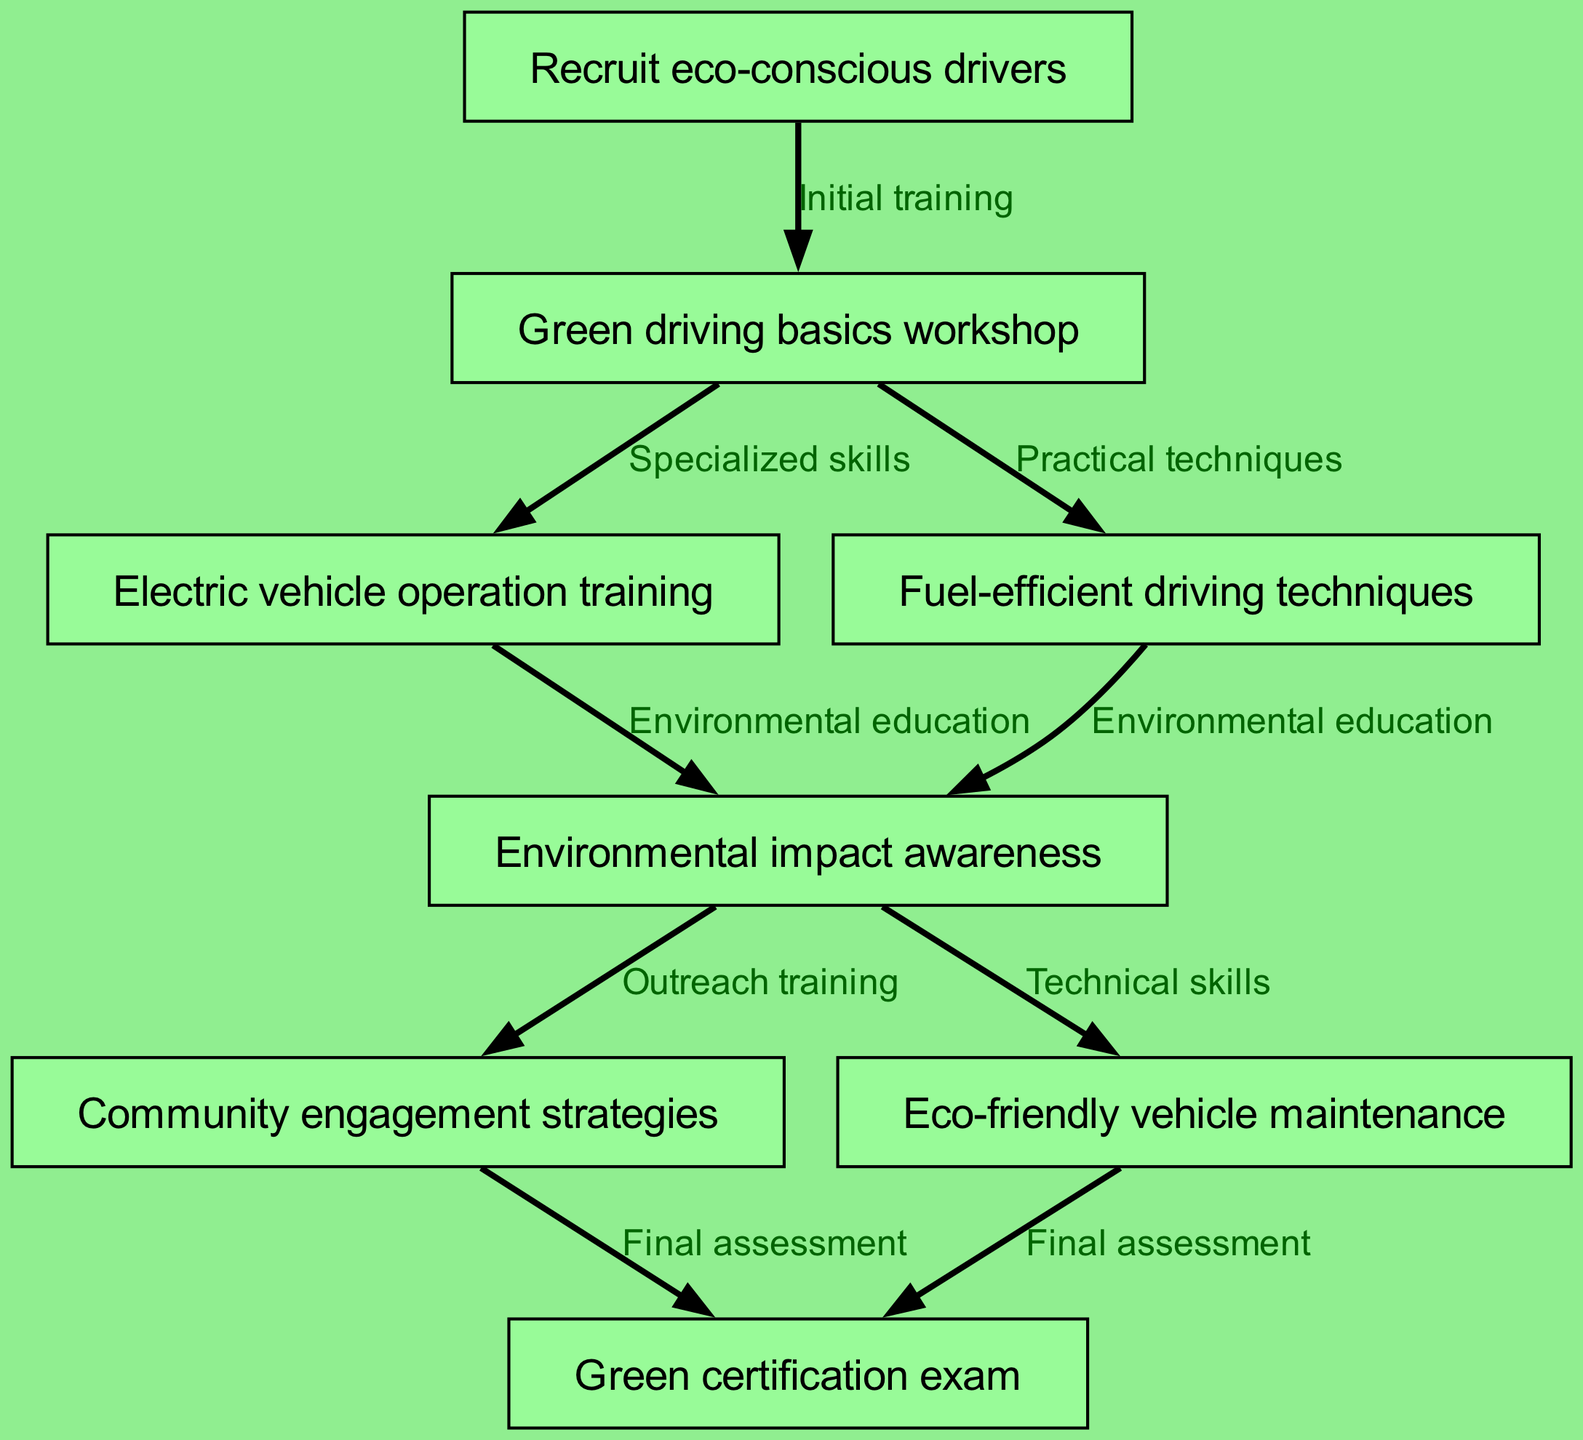What is the first step in the training pathway? The first step is represented by the initial node labeled "Recruit eco-conscious drivers." This is the starting point of the pathway, indicating that the recruitment of drivers is the prerequisite for moving forward in the training process.
Answer: Recruit eco-conscious drivers How many nodes are present in the diagram? To determine the number of nodes, we count each of the unique entities listed in the data under the "nodes" section. There are a total of eight distinct nodes described.
Answer: 8 What training follows the "Green driving basics workshop"? The "Green driving basics workshop" node connects to two specialized areas. The training that follows includes "Electric vehicle operation training" and "Fuel-efficient driving techniques." Thus, either of these can be considered as direct follow-ups.
Answer: Electric vehicle operation training, Fuel-efficient driving techniques Which node represents the final assessment of the training pathway? The final assessment is captured in the node identified as "Green certification exam." This node comes last in the flow as it is reached after all training components have been completed.
Answer: Green certification exam What is the relationship between "Environmental impact awareness" and "Community engagement strategies"? "Environmental impact awareness" is a preceding node that leads into "Community engagement strategies." After understanding the environmental impacts, drivers can develop strategies for engaging with the community regarding environmental issues.
Answer: Outreach training 